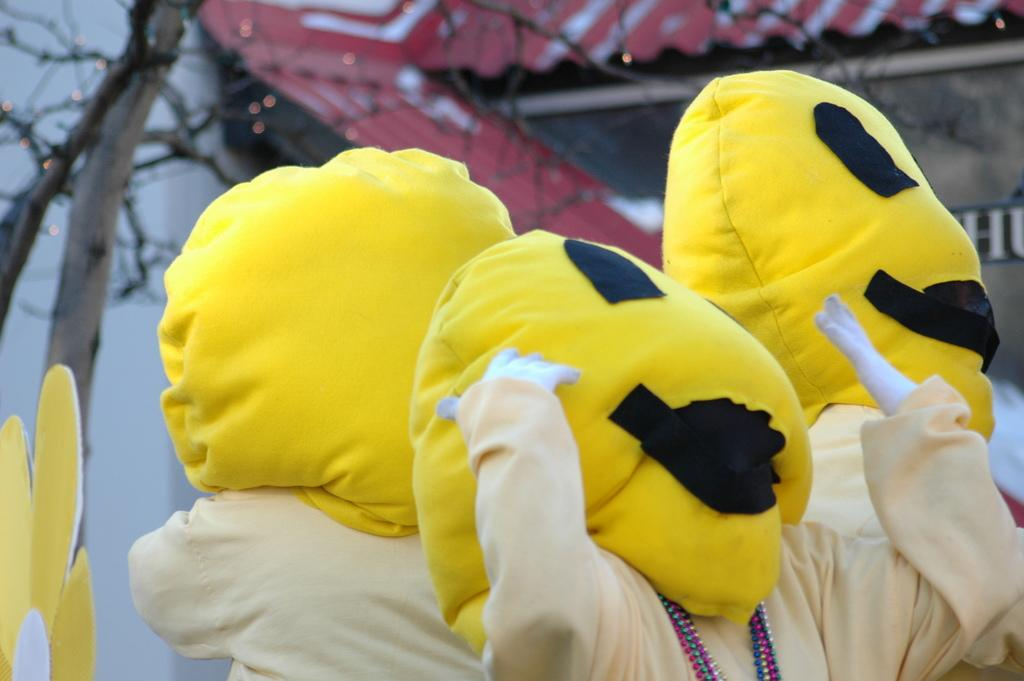What type of characters are present in the image? There are clowns in the image. What structure can be seen in the background of the image? There is a shed in the background of the image. What type of vegetation is on the left side of the image? There is a tree on the left side of the image. What songs are the clowns singing in the image? There is no information about songs in the image; it only shows the presence of clowns. What type of pets are accompanying the clowns in the image? There is no information about pets in the image; it only shows the presence of clowns. 